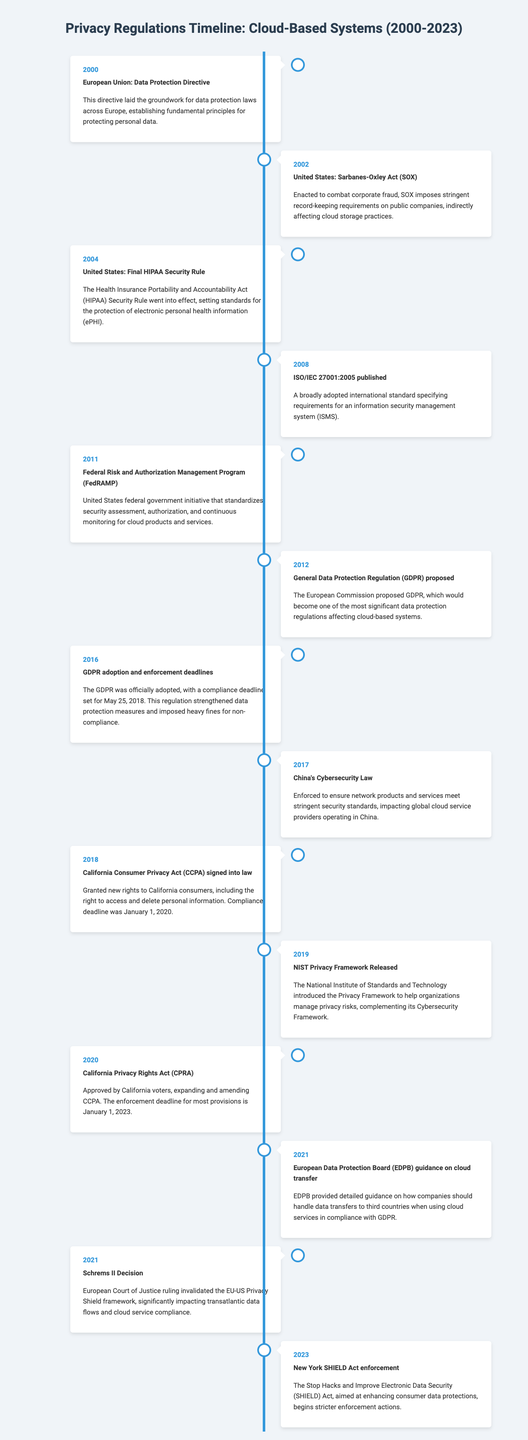What legislation was enacted in 2000? The document states that the European Union established the Data Protection Directive in 2000.
Answer: Data Protection Directive What was the compliance deadline for the GDPR? The document mentions that the compliance deadline for the GDPR was set for May 25, 2018.
Answer: May 25, 2018 Which act was signed into law in 2018? According to the timeline, the California Consumer Privacy Act (CCPA) was signed into law in 2018.
Answer: California Consumer Privacy Act (CCPA) What significant event occurred in 2016 regarding privacy regulations? The timeline indicates that the GDPR was officially adopted in 2016.
Answer: GDPR adoption Which year's event involved FedRAMP? The timeline specifies that FedRAMP was introduced in 2011.
Answer: 2011 How did the 2021 Schrems II Decision impact data flows? The document explains that the ruling invalidated the EU-US Privacy Shield framework, affecting transatlantic data flows.
Answer: Invalidated the EU-US Privacy Shield What specific type of guidance did the EDPB provide in 2021? The document states that the EDPB provided guidance on data transfers to third countries.
Answer: Guidance on data transfers When does the enforcement of the CPRA begin? The timeline indicates that the enforcement deadline for most CPRA provisions is January 1, 2023.
Answer: January 1, 2023 How many major events are listed for the year 2021? The timeline shows that two significant events occurred in 2021.
Answer: Two events 